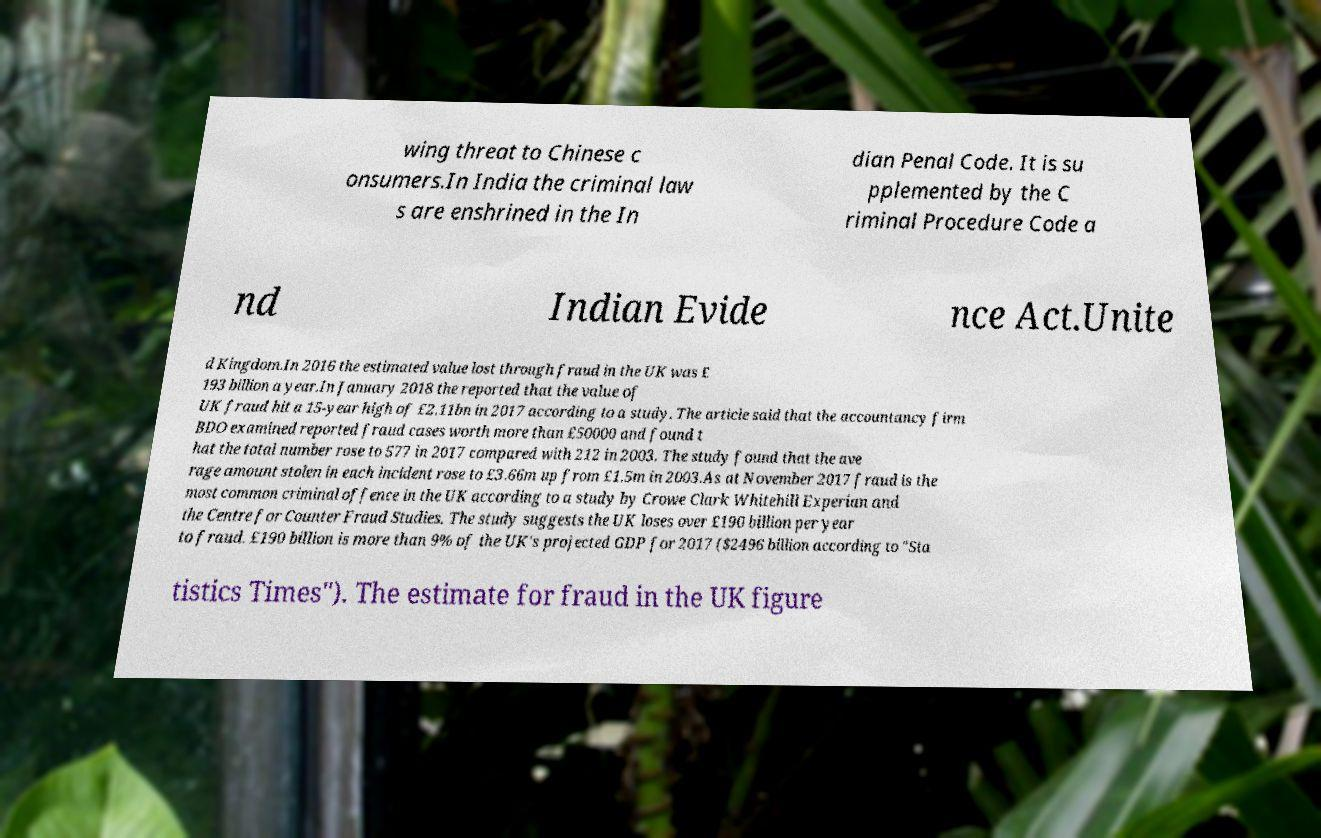Could you extract and type out the text from this image? wing threat to Chinese c onsumers.In India the criminal law s are enshrined in the In dian Penal Code. It is su pplemented by the C riminal Procedure Code a nd Indian Evide nce Act.Unite d Kingdom.In 2016 the estimated value lost through fraud in the UK was £ 193 billion a year.In January 2018 the reported that the value of UK fraud hit a 15-year high of £2.11bn in 2017 according to a study. The article said that the accountancy firm BDO examined reported fraud cases worth more than £50000 and found t hat the total number rose to 577 in 2017 compared with 212 in 2003. The study found that the ave rage amount stolen in each incident rose to £3.66m up from £1.5m in 2003.As at November 2017 fraud is the most common criminal offence in the UK according to a study by Crowe Clark Whitehill Experian and the Centre for Counter Fraud Studies. The study suggests the UK loses over £190 billion per year to fraud. £190 billion is more than 9% of the UK's projected GDP for 2017 ($2496 billion according to "Sta tistics Times"). The estimate for fraud in the UK figure 